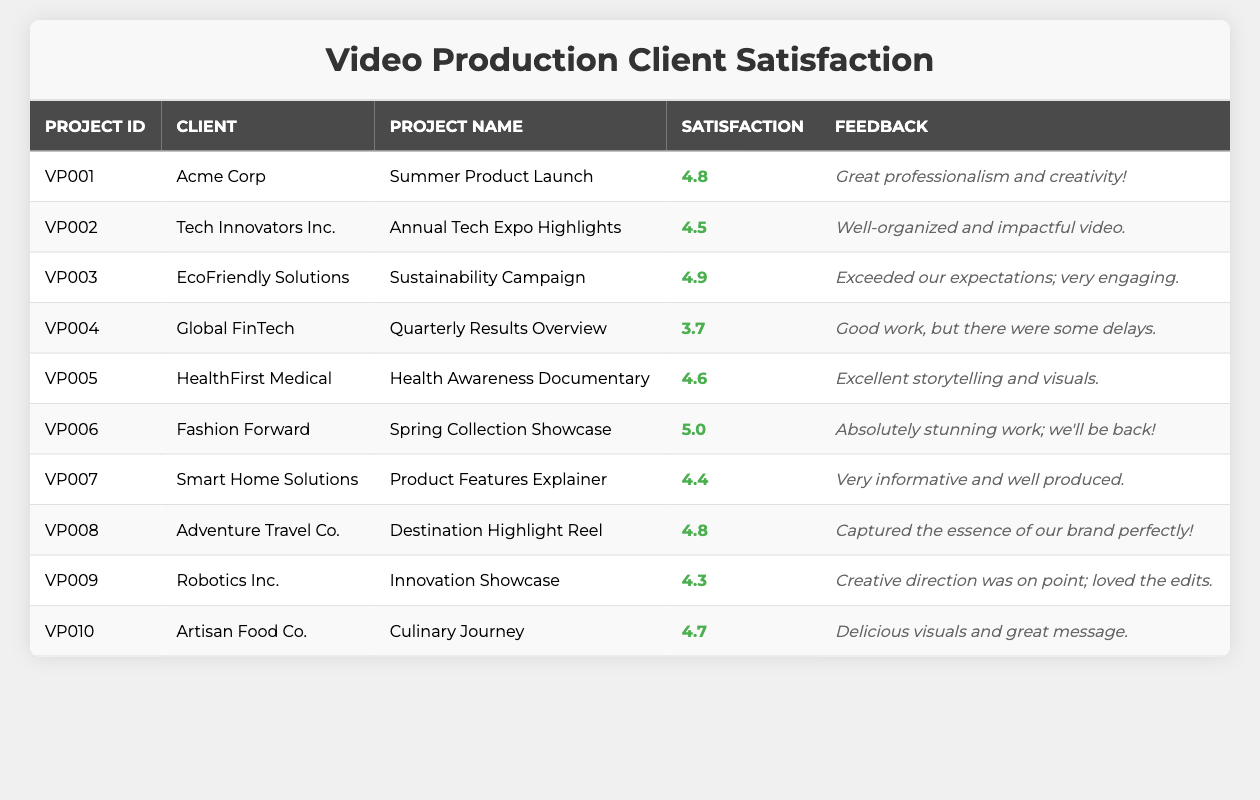What is the highest satisfaction rating in the table? Looking through the satisfaction ratings, the highest rating is listed for the project "Spring Collection Showcase" by Fashion Forward, which has a rating of 5.0
Answer: 5.0 Which client gave feedback about delays? The feedback mentioning delays comes from Global FinTech for their project "Quarterly Results Overview," which received a rating of 3.7
Answer: Global FinTech What is the average satisfaction rating across all projects? To find the average, sum the satisfaction ratings: (4.8 + 4.5 + 4.9 + 3.7 + 4.6 + 5.0 + 4.4 + 4.8 + 4.3 + 4.7) = 48.7. There are 10 projects, so the average is 48.7 / 10 = 4.87
Answer: 4.87 Is there any project with a satisfaction rating below 4.0? Reviewing the ratings, the only project with a rating below 4.0 is provided by Global FinTech, which has a rating of 3.7. Therefore, yes, there is a project below 4.0
Answer: Yes Which project has the second highest satisfaction rating? The projects with the highest ratings are "Spring Collection Showcase" at 5.0 and "Sustainability Campaign" at 4.9. Therefore, "Sustainability Campaign" is the second highest with a rating of 4.9
Answer: Sustainability Campaign How many projects received a satisfaction rating of 4.5 or higher? Counting the ratings of 4.5 and above: VP001, VP002, VP003, VP005, VP006, VP007, VP008, VP010 are the valid projects which sum to 8.
Answer: 8 What is the feedback for the project with the lowest rating? The project with the lowest rating of 3.7 is "Quarterly Results Overview" by Global FinTech, and the feedback received was, "Good work, but there were some delays."
Answer: Good work, but there were some delays Which client provided the most positive feedback? The feedback from "Fashion Forward" for the "Spring Collection Showcase" is rated 5.0 and describes their work as "Absolutely stunning work; we'll be back!" making it the most positive feedback.
Answer: Fashion Forward What percentage of projects have a satisfaction rating of 4.6 or higher? There are 10 projects in total, and the projects with ratings of 4.6 or higher are VP001, VP003, VP005, VP006, VP008, and VP010, totaling 6 projects. The percentage is (6/10)*100 = 60%.
Answer: 60% Is the feedback for "Health Awareness Documentary" positive? The feedback states, "Excellent storytelling and visuals," which represents positive feedback. Thus, it can be concluded that the feedback is indeed positive.
Answer: Yes 